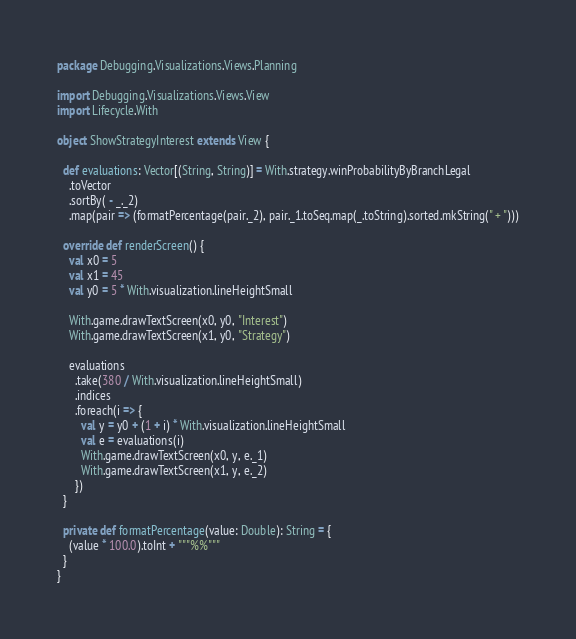Convert code to text. <code><loc_0><loc_0><loc_500><loc_500><_Scala_>package Debugging.Visualizations.Views.Planning

import Debugging.Visualizations.Views.View
import Lifecycle.With

object ShowStrategyInterest extends View {

  def evaluations: Vector[(String, String)] = With.strategy.winProbabilityByBranchLegal
    .toVector
    .sortBy( - _._2)
    .map(pair => (formatPercentage(pair._2), pair._1.toSeq.map(_.toString).sorted.mkString(" + ")))
  
  override def renderScreen() {
    val x0 = 5
    val x1 = 45
    val y0 = 5 * With.visualization.lineHeightSmall
  
    With.game.drawTextScreen(x0, y0, "Interest")
    With.game.drawTextScreen(x1, y0, "Strategy")
    
    evaluations
      .take(380 / With.visualization.lineHeightSmall)
      .indices
      .foreach(i => {
        val y = y0 + (1 + i) * With.visualization.lineHeightSmall
        val e = evaluations(i)
        With.game.drawTextScreen(x0, y, e._1)
        With.game.drawTextScreen(x1, y, e._2)
      })
  }
  
  private def formatPercentage(value: Double): String = {
    (value * 100.0).toInt + """%%"""
  }
}
</code> 